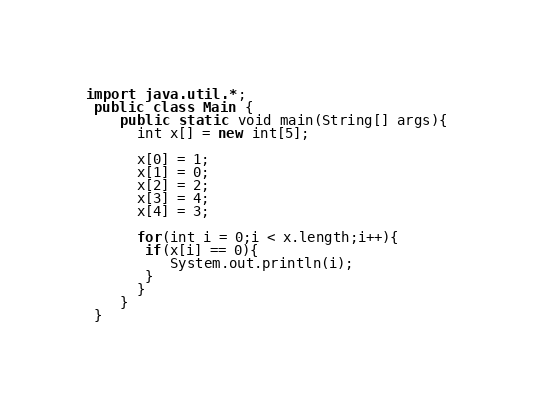Convert code to text. <code><loc_0><loc_0><loc_500><loc_500><_Java_>import java.util.*;
 public class Main {
	public static void main(String[] args){
      int x[] = new int[5];

      x[0] = 1;
      x[1] = 0;
      x[2] = 2;
      x[3] = 4;
      x[4] = 3;
      
      for(int i = 0;i < x.length;i++){
       if(x[i] == 0){
          System.out.println(i);
       }
      }
	}
 }



</code> 